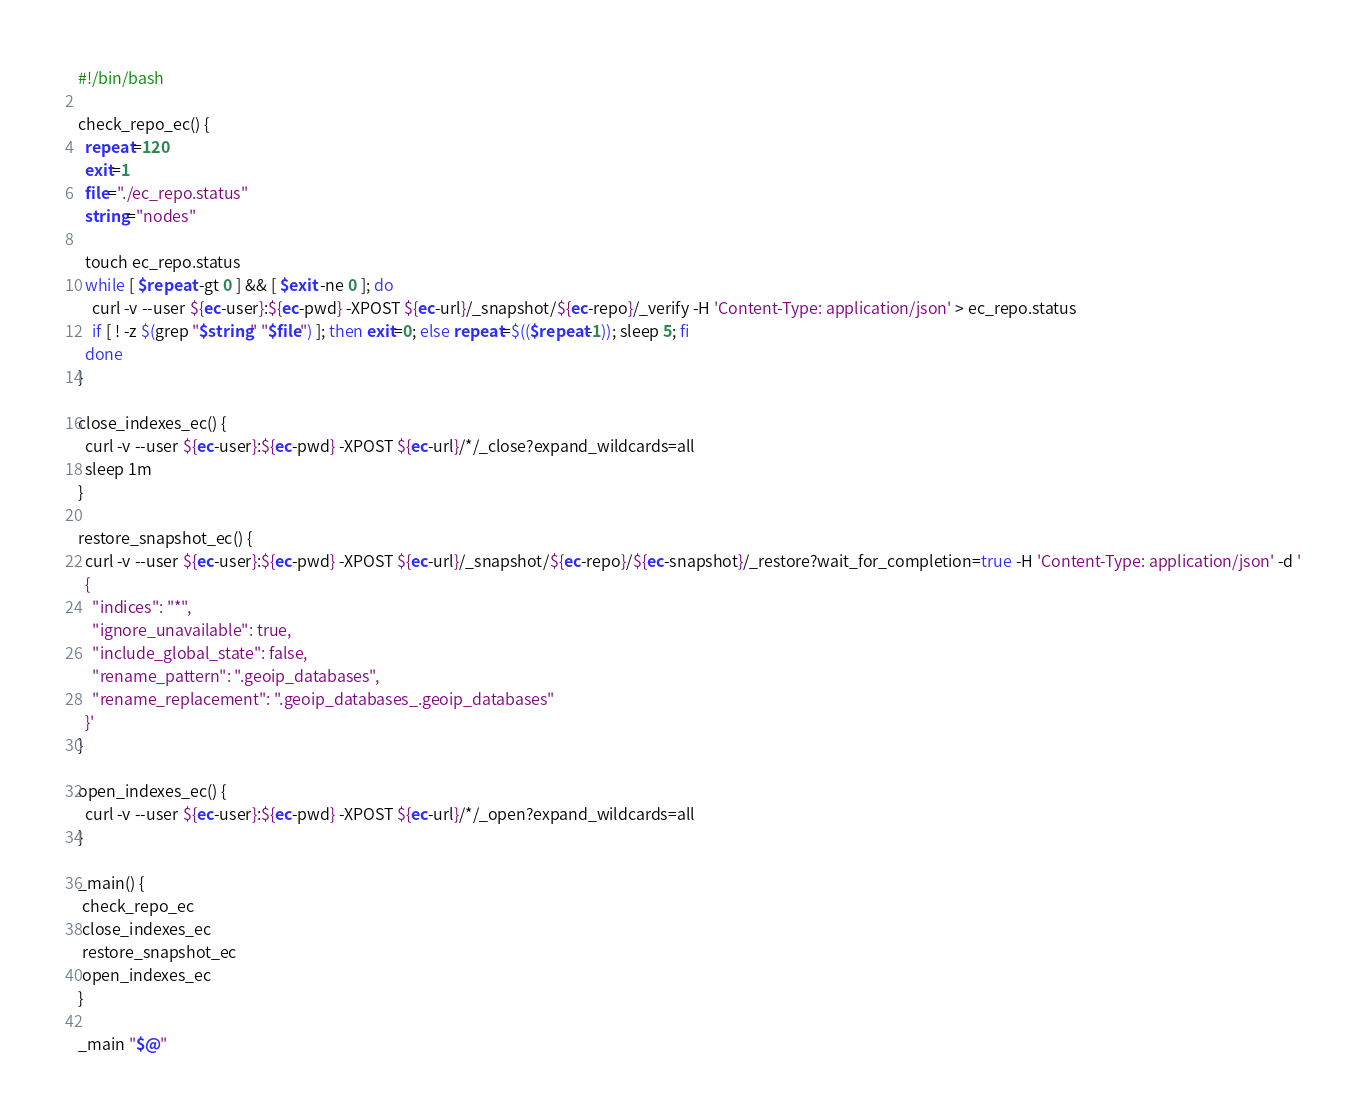Convert code to text. <code><loc_0><loc_0><loc_500><loc_500><_Bash_>#!/bin/bash

check_repo_ec() {
  repeat=120
  exit=1
  file="./ec_repo.status"
  string="nodes"

  touch ec_repo.status
  while [ $repeat -gt 0 ] && [ $exit -ne 0 ]; do
    curl -v --user ${ec-user}:${ec-pwd} -XPOST ${ec-url}/_snapshot/${ec-repo}/_verify -H 'Content-Type: application/json' > ec_repo.status
    if [ ! -z $(grep "$string" "$file") ]; then exit=0; else repeat=$(($repeat-1)); sleep 5; fi
  done
}

close_indexes_ec() {
  curl -v --user ${ec-user}:${ec-pwd} -XPOST ${ec-url}/*/_close?expand_wildcards=all
  sleep 1m
}

restore_snapshot_ec() {
  curl -v --user ${ec-user}:${ec-pwd} -XPOST ${ec-url}/_snapshot/${ec-repo}/${ec-snapshot}/_restore?wait_for_completion=true -H 'Content-Type: application/json' -d '
  {
    "indices": "*",
    "ignore_unavailable": true,
    "include_global_state": false,
    "rename_pattern": ".geoip_databases",
    "rename_replacement": ".geoip_databases_.geoip_databases"
  }'
}

open_indexes_ec() {
  curl -v --user ${ec-user}:${ec-pwd} -XPOST ${ec-url}/*/_open?expand_wildcards=all
}

_main() {
 check_repo_ec
 close_indexes_ec
 restore_snapshot_ec
 open_indexes_ec
}

_main "$@"</code> 